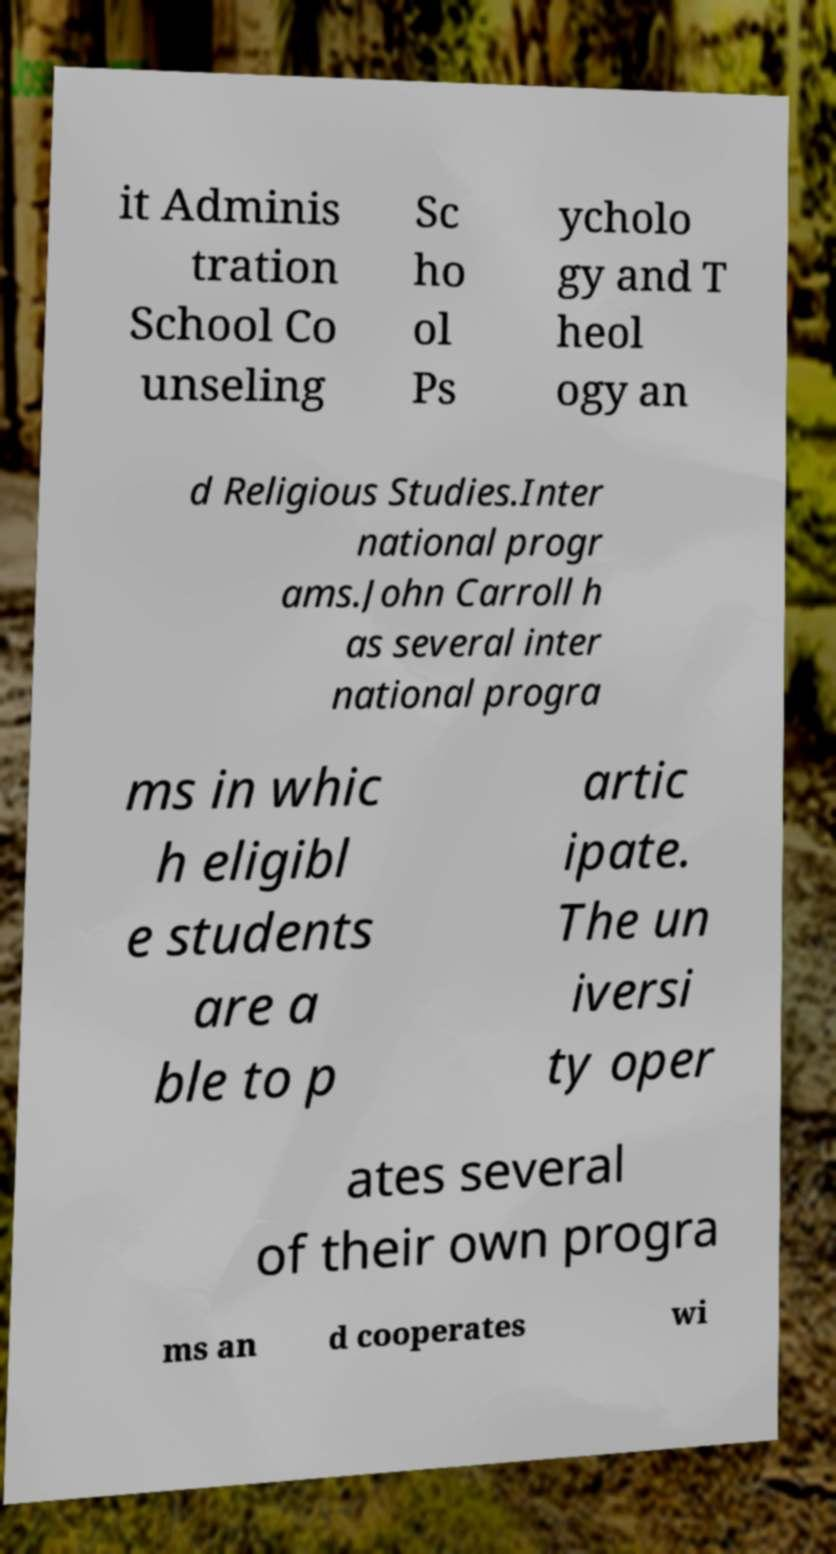For documentation purposes, I need the text within this image transcribed. Could you provide that? it Adminis tration School Co unseling Sc ho ol Ps ycholo gy and T heol ogy an d Religious Studies.Inter national progr ams.John Carroll h as several inter national progra ms in whic h eligibl e students are a ble to p artic ipate. The un iversi ty oper ates several of their own progra ms an d cooperates wi 